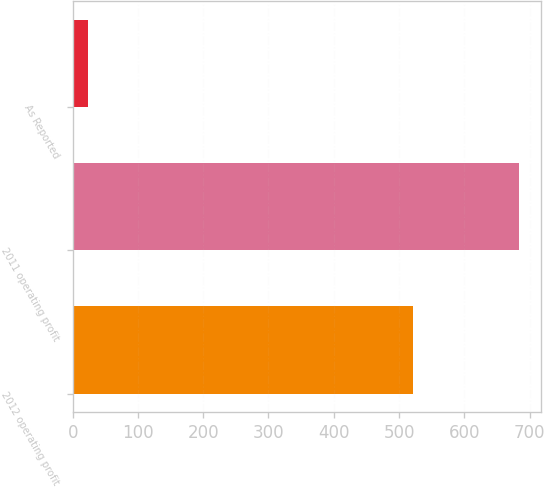<chart> <loc_0><loc_0><loc_500><loc_500><bar_chart><fcel>2012 operating profit<fcel>2011 operating profit<fcel>As Reported<nl><fcel>521<fcel>684<fcel>23.8<nl></chart> 